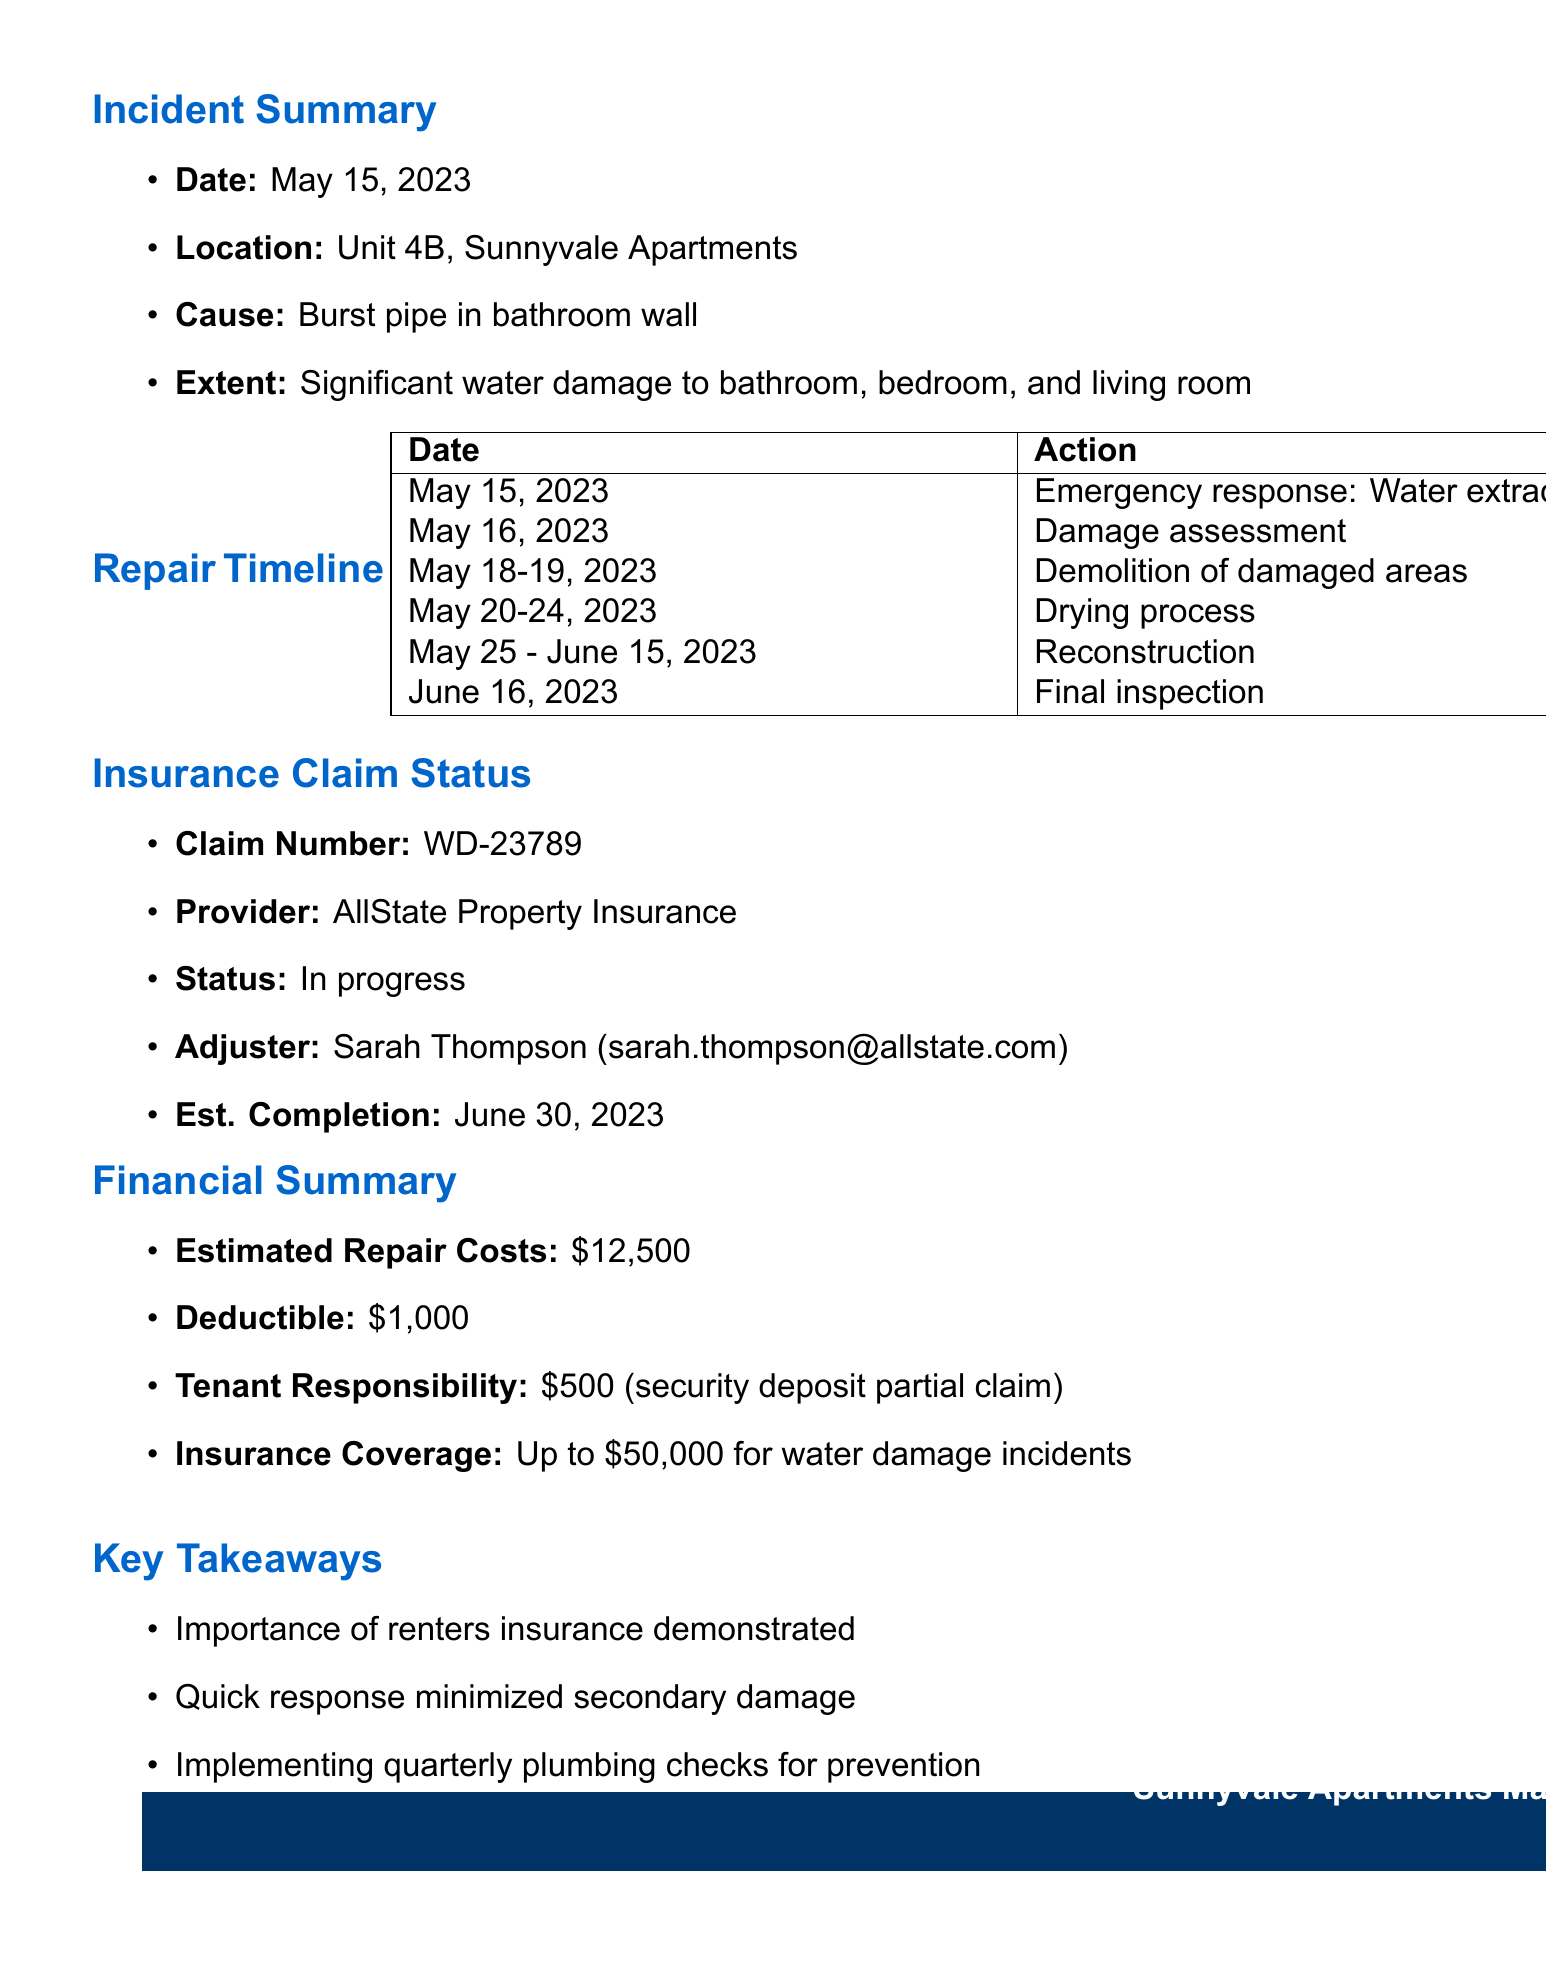What is the date of the water damage incident? The date of the incident is specified in the document.
Answer: May 15, 2023 What area had significant water damage? The document lists the affected areas, which shows where the damage occurred.
Answer: Bathroom, Bedroom, Living room Who is the insurance adjuster? The adjuster's information is noted in the insurance claim status section.
Answer: Sarah Thompson What is the total estimated repair cost? The financial summary provides details about the costs related to the damage.
Answer: $12,500 What is the current status of the insurance claim? The insurance claim status outlines where the claim currently stands in the process.
Answer: In progress When was the damage assessment conducted? The timeline section provides the date of the damage assessment after the incident.
Answer: May 16, 2023 What lessons were learned regarding renters insurance? The lessons learned section discusses the importance of renters insurance in relation to the incident.
Answer: Reduced out-of-pocket expenses How long was the temporary housing arranged for the tenant? The action taken regarding temporary housing is listed in the document.
Answer: 2 weeks What is the estimated completion date for the insurance claim? The insurance claim status indicates when the claim is expected to be completed.
Answer: June 30, 2023 